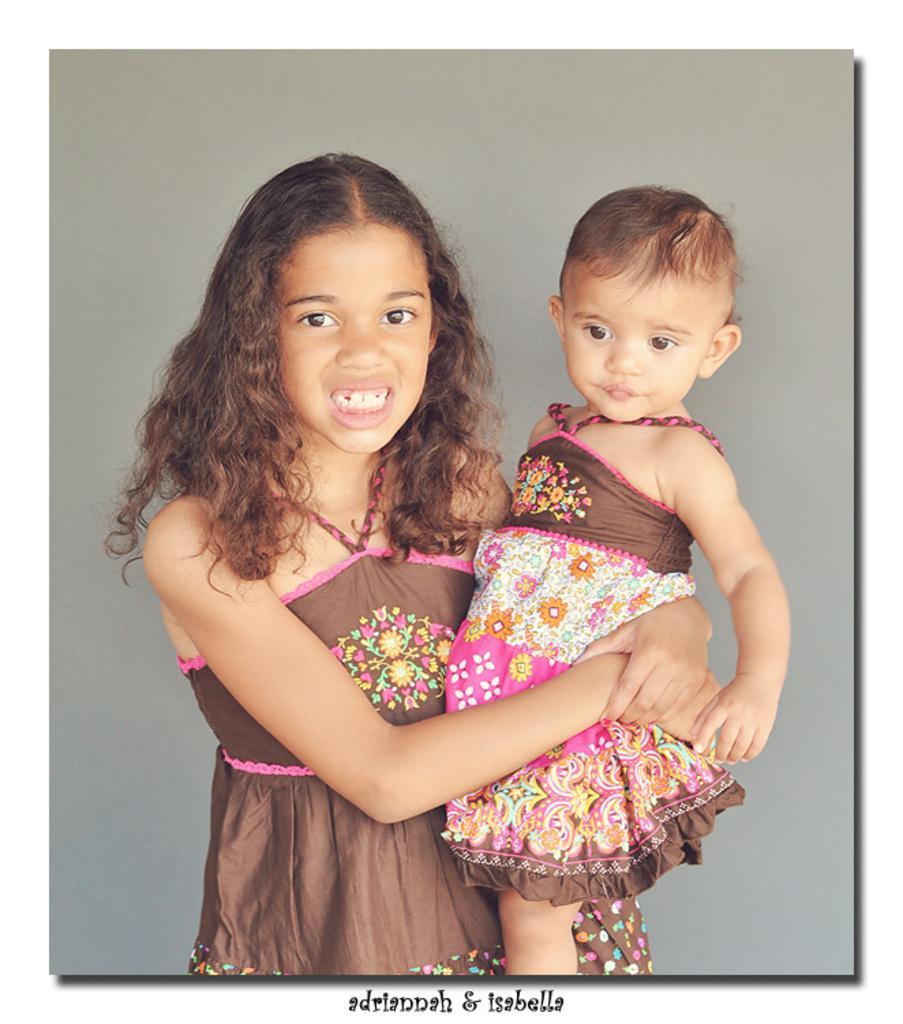Could you give a brief overview of what you see in this image? In this image, we can see a girl standing and she is holding a small baby girl. 